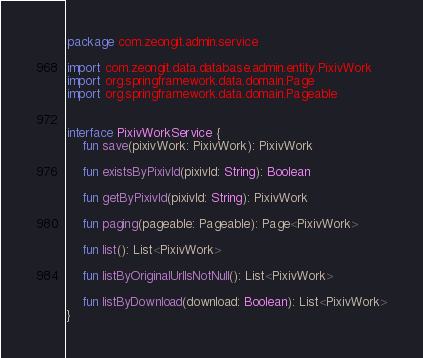Convert code to text. <code><loc_0><loc_0><loc_500><loc_500><_Kotlin_>package com.zeongit.admin.service

import com.zeongit.data.database.admin.entity.PixivWork
import org.springframework.data.domain.Page
import org.springframework.data.domain.Pageable


interface PixivWorkService {
    fun save(pixivWork: PixivWork): PixivWork

    fun existsByPixivId(pixivId: String): Boolean

    fun getByPixivId(pixivId: String): PixivWork

    fun paging(pageable: Pageable): Page<PixivWork>

    fun list(): List<PixivWork>

    fun listByOriginalUrlIsNotNull(): List<PixivWork>

    fun listByDownload(download: Boolean): List<PixivWork>
}</code> 